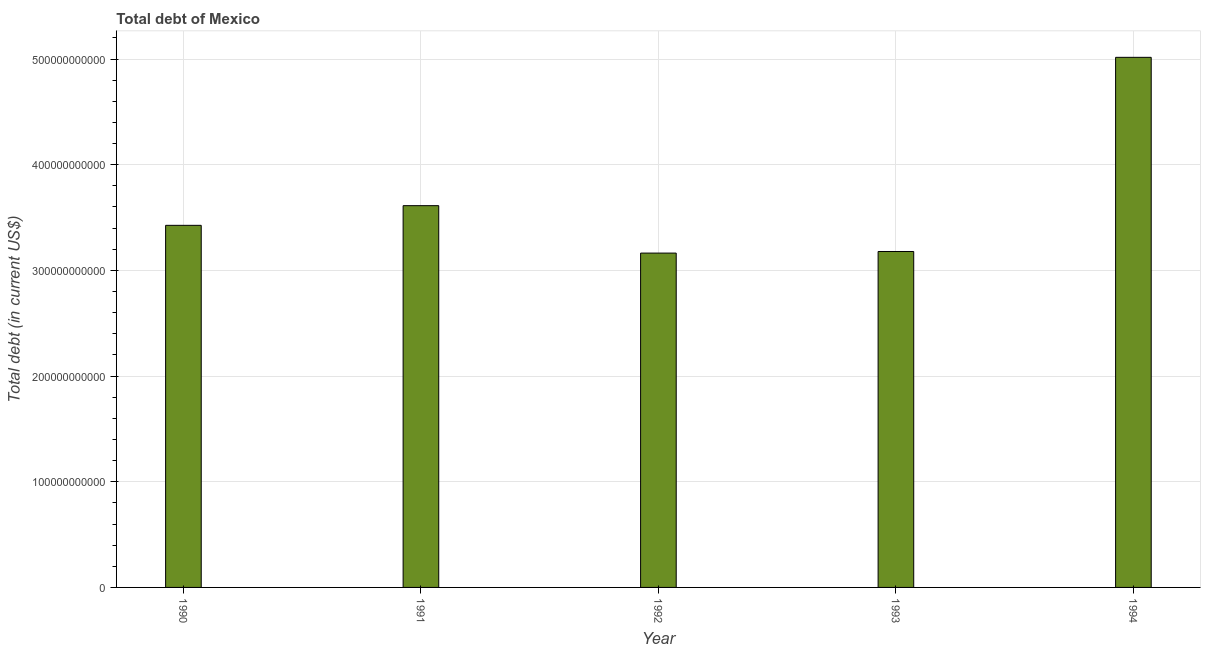Does the graph contain any zero values?
Provide a succinct answer. No. What is the title of the graph?
Your answer should be compact. Total debt of Mexico. What is the label or title of the X-axis?
Offer a very short reply. Year. What is the label or title of the Y-axis?
Your answer should be very brief. Total debt (in current US$). What is the total debt in 1990?
Provide a short and direct response. 3.43e+11. Across all years, what is the maximum total debt?
Ensure brevity in your answer.  5.02e+11. Across all years, what is the minimum total debt?
Keep it short and to the point. 3.16e+11. In which year was the total debt maximum?
Keep it short and to the point. 1994. In which year was the total debt minimum?
Your answer should be compact. 1992. What is the sum of the total debt?
Offer a very short reply. 1.84e+12. What is the difference between the total debt in 1990 and 1994?
Provide a short and direct response. -1.59e+11. What is the average total debt per year?
Ensure brevity in your answer.  3.68e+11. What is the median total debt?
Keep it short and to the point. 3.43e+11. In how many years, is the total debt greater than 380000000000 US$?
Your answer should be compact. 1. What is the ratio of the total debt in 1991 to that in 1992?
Keep it short and to the point. 1.14. Is the total debt in 1992 less than that in 1994?
Make the answer very short. Yes. What is the difference between the highest and the second highest total debt?
Ensure brevity in your answer.  1.40e+11. Is the sum of the total debt in 1990 and 1992 greater than the maximum total debt across all years?
Provide a short and direct response. Yes. What is the difference between the highest and the lowest total debt?
Offer a terse response. 1.85e+11. How many bars are there?
Give a very brief answer. 5. What is the difference between two consecutive major ticks on the Y-axis?
Offer a very short reply. 1.00e+11. What is the Total debt (in current US$) of 1990?
Offer a very short reply. 3.43e+11. What is the Total debt (in current US$) in 1991?
Your answer should be very brief. 3.61e+11. What is the Total debt (in current US$) of 1992?
Provide a succinct answer. 3.16e+11. What is the Total debt (in current US$) of 1993?
Offer a very short reply. 3.18e+11. What is the Total debt (in current US$) of 1994?
Make the answer very short. 5.02e+11. What is the difference between the Total debt (in current US$) in 1990 and 1991?
Keep it short and to the point. -1.86e+1. What is the difference between the Total debt (in current US$) in 1990 and 1992?
Provide a short and direct response. 2.63e+1. What is the difference between the Total debt (in current US$) in 1990 and 1993?
Your answer should be very brief. 2.47e+1. What is the difference between the Total debt (in current US$) in 1990 and 1994?
Provide a succinct answer. -1.59e+11. What is the difference between the Total debt (in current US$) in 1991 and 1992?
Give a very brief answer. 4.49e+1. What is the difference between the Total debt (in current US$) in 1991 and 1993?
Ensure brevity in your answer.  4.34e+1. What is the difference between the Total debt (in current US$) in 1991 and 1994?
Offer a terse response. -1.40e+11. What is the difference between the Total debt (in current US$) in 1992 and 1993?
Offer a very short reply. -1.52e+09. What is the difference between the Total debt (in current US$) in 1992 and 1994?
Your answer should be very brief. -1.85e+11. What is the difference between the Total debt (in current US$) in 1993 and 1994?
Your answer should be very brief. -1.84e+11. What is the ratio of the Total debt (in current US$) in 1990 to that in 1991?
Your response must be concise. 0.95. What is the ratio of the Total debt (in current US$) in 1990 to that in 1992?
Provide a short and direct response. 1.08. What is the ratio of the Total debt (in current US$) in 1990 to that in 1993?
Offer a very short reply. 1.08. What is the ratio of the Total debt (in current US$) in 1990 to that in 1994?
Give a very brief answer. 0.68. What is the ratio of the Total debt (in current US$) in 1991 to that in 1992?
Ensure brevity in your answer.  1.14. What is the ratio of the Total debt (in current US$) in 1991 to that in 1993?
Your answer should be compact. 1.14. What is the ratio of the Total debt (in current US$) in 1991 to that in 1994?
Provide a short and direct response. 0.72. What is the ratio of the Total debt (in current US$) in 1992 to that in 1993?
Offer a terse response. 0.99. What is the ratio of the Total debt (in current US$) in 1992 to that in 1994?
Offer a very short reply. 0.63. What is the ratio of the Total debt (in current US$) in 1993 to that in 1994?
Ensure brevity in your answer.  0.63. 